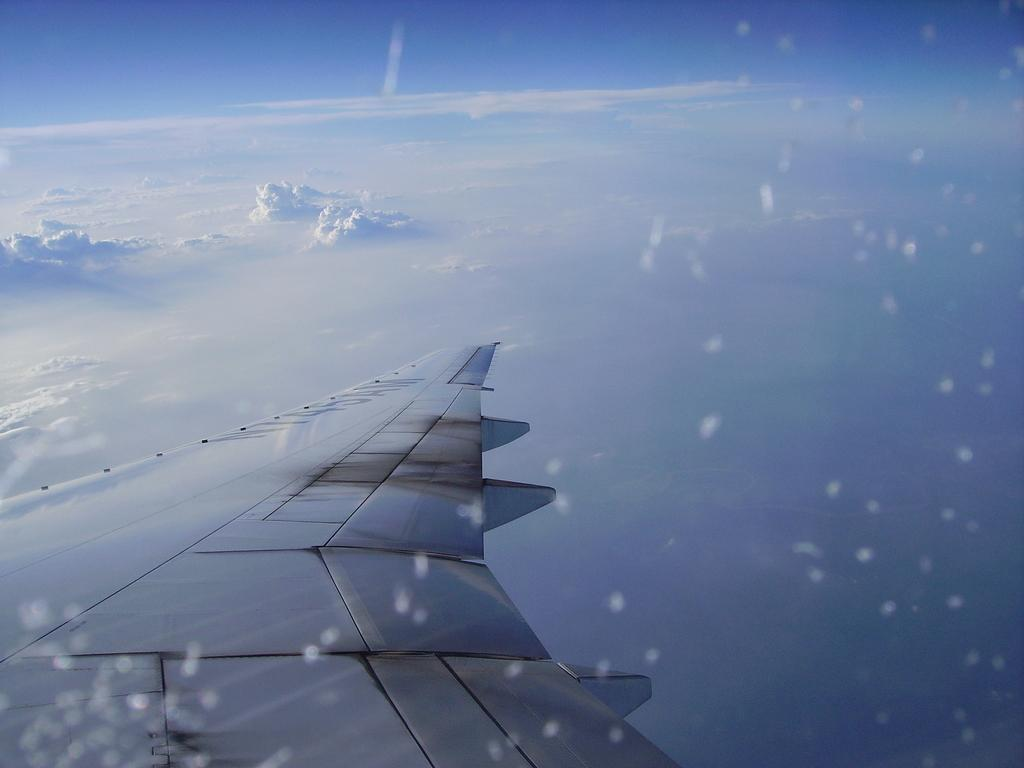What is the main subject of the image? The main subject of the image is an airplane wing. Where is the airplane wing located in the image? The airplane wing is in the air. What can be seen in the background of the image? The sky is visible in the image. What is the condition of the sky in the image? Clouds are present in the sky. What type of cake is being served on the airplane wing in the image? There is no cake present in the image, as it features an airplane wing in the air. How many feet are visible on the airplane wing in the image? Airplane wings do not have feet, so this question cannot be answered. 